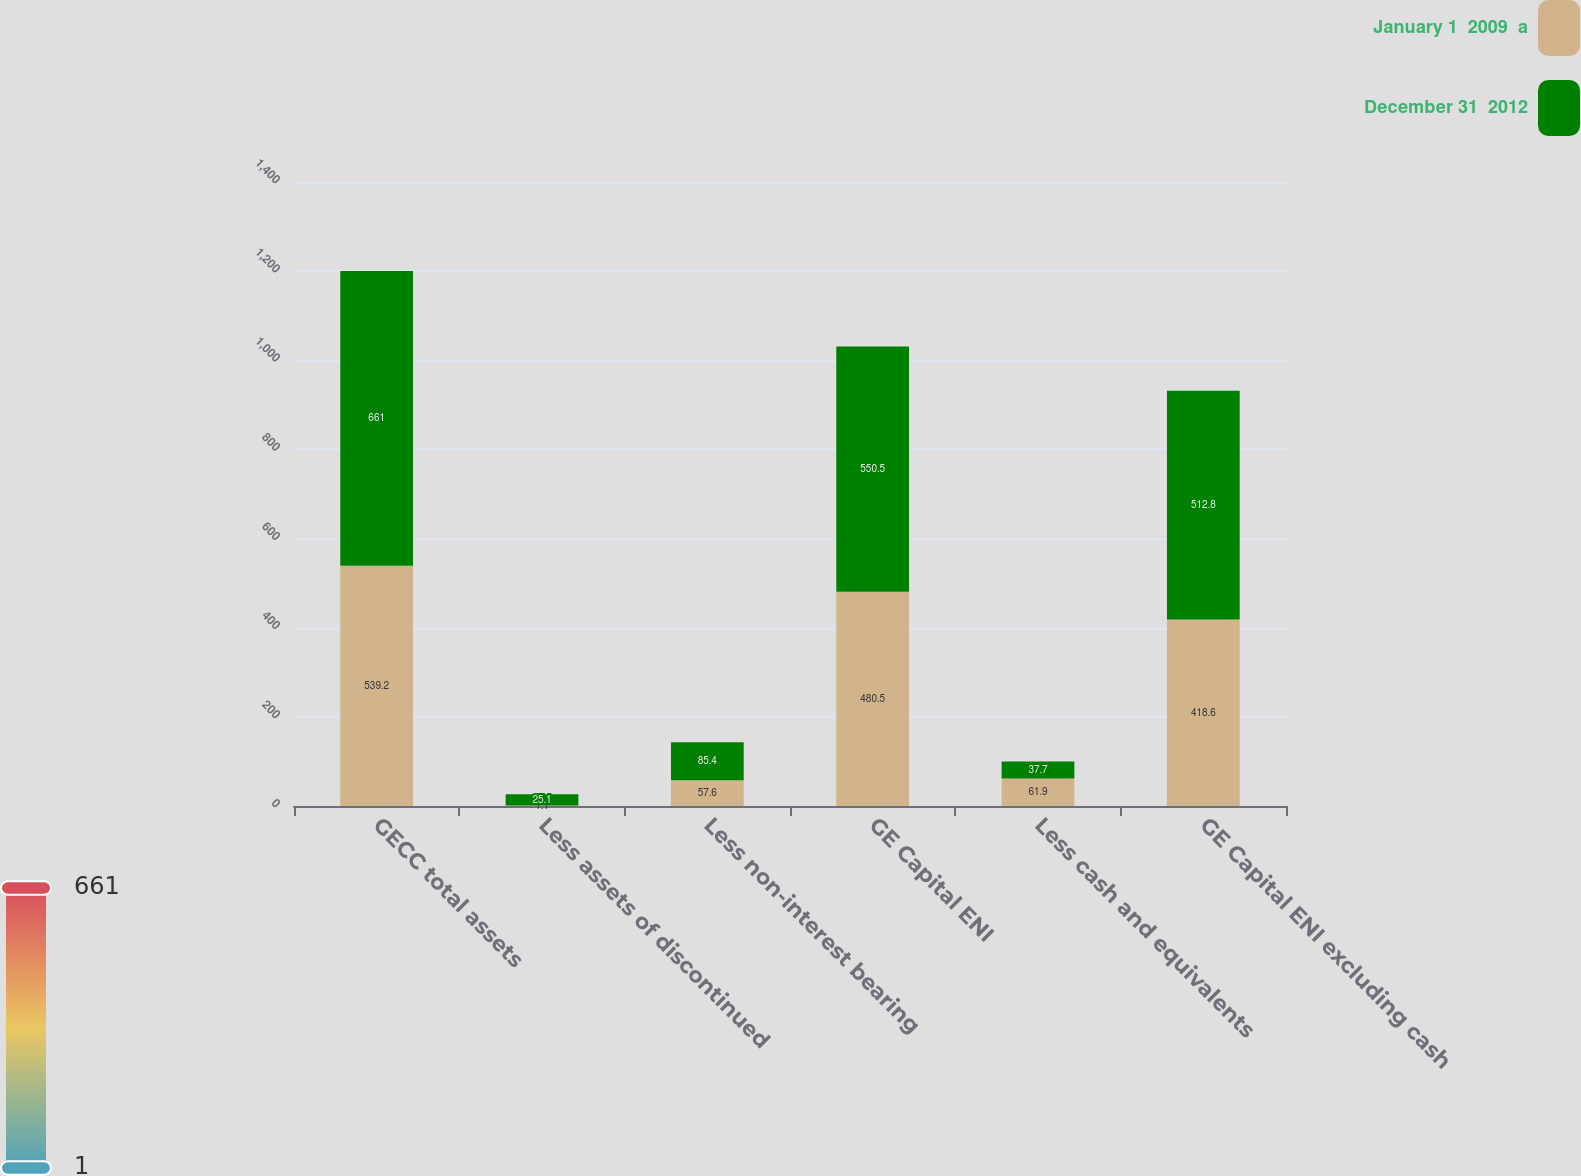<chart> <loc_0><loc_0><loc_500><loc_500><stacked_bar_chart><ecel><fcel>GECC total assets<fcel>Less assets of discontinued<fcel>Less non-interest bearing<fcel>GE Capital ENI<fcel>Less cash and equivalents<fcel>GE Capital ENI excluding cash<nl><fcel>January 1  2009  a<fcel>539.2<fcel>1.1<fcel>57.6<fcel>480.5<fcel>61.9<fcel>418.6<nl><fcel>December 31  2012<fcel>661<fcel>25.1<fcel>85.4<fcel>550.5<fcel>37.7<fcel>512.8<nl></chart> 